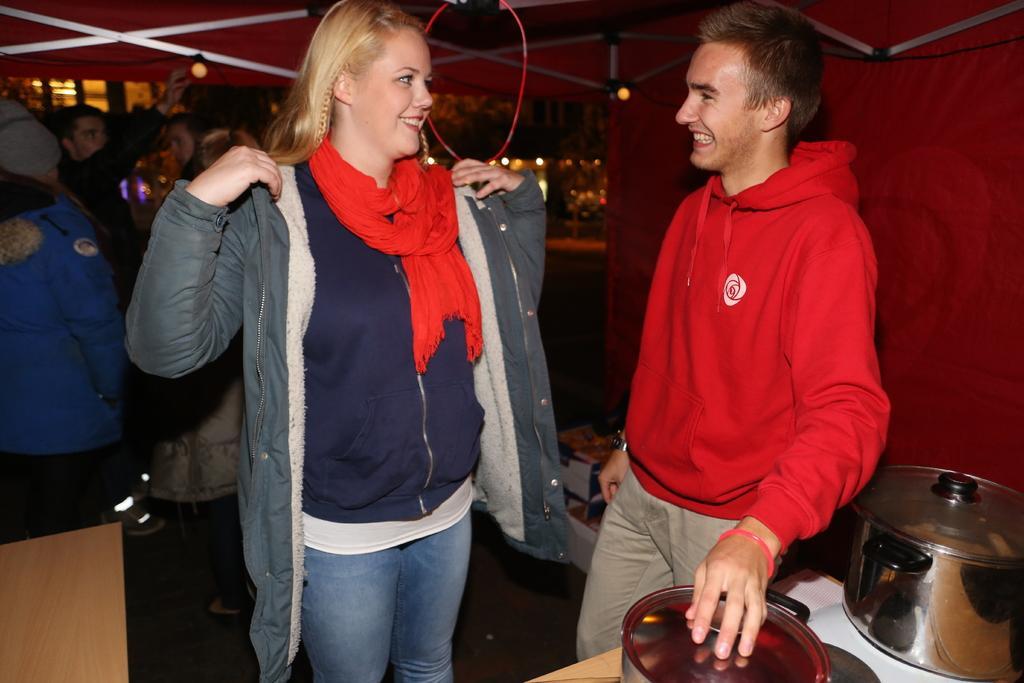Please provide a concise description of this image. In this image we can see two persons. On the right side of the object there are utensils on an object. In the background of the image there are some people, lights and other objects. On the left side of the image there is an object. 